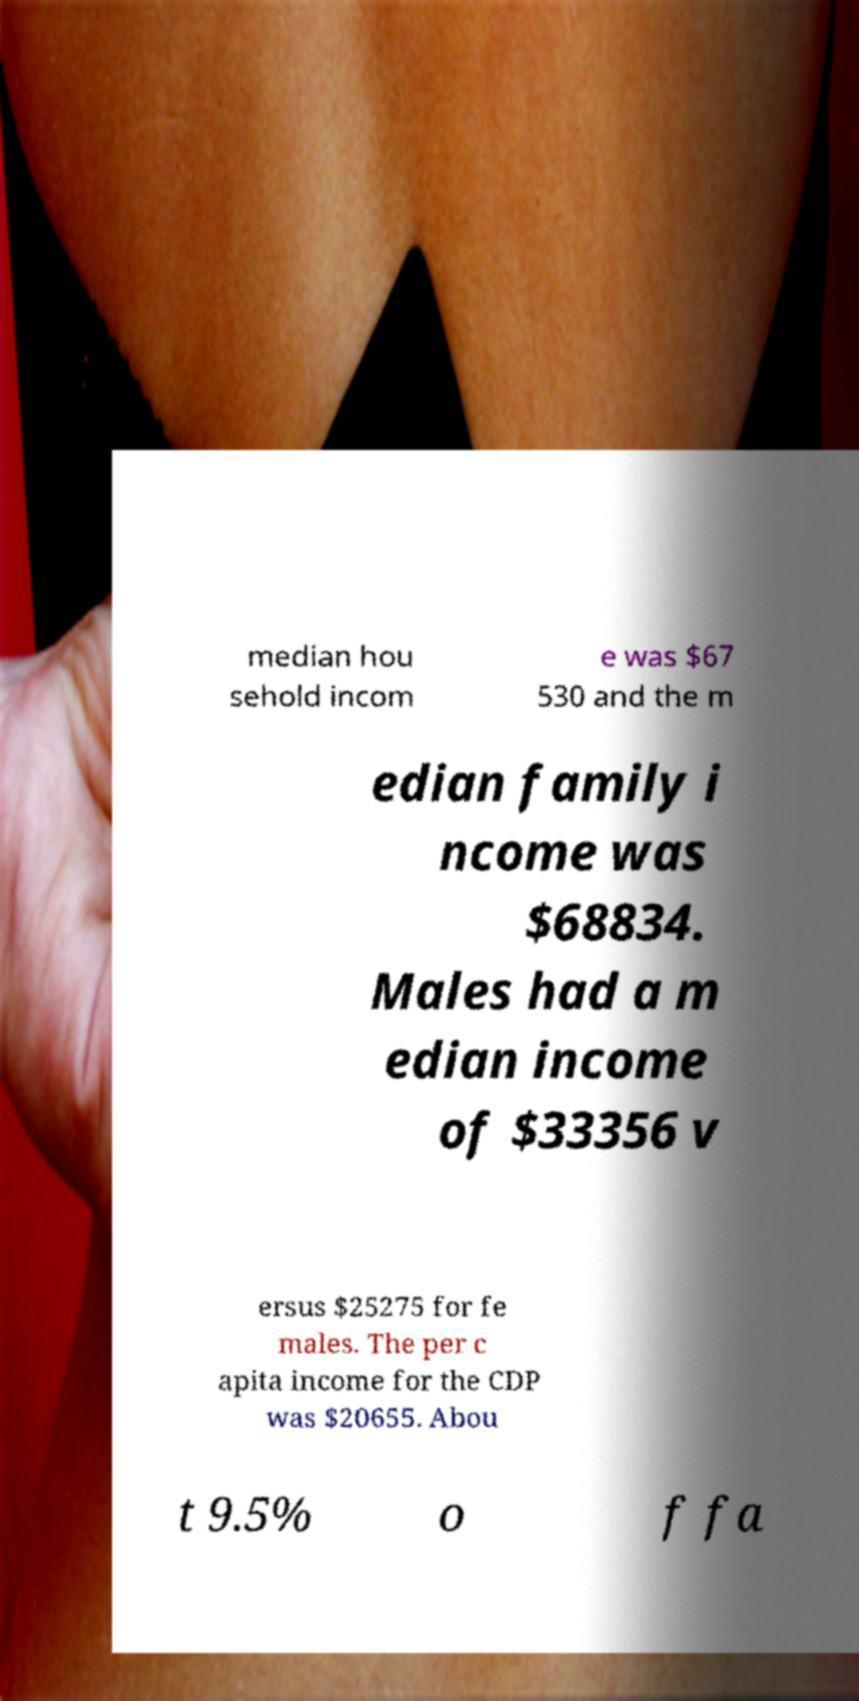There's text embedded in this image that I need extracted. Can you transcribe it verbatim? median hou sehold incom e was $67 530 and the m edian family i ncome was $68834. Males had a m edian income of $33356 v ersus $25275 for fe males. The per c apita income for the CDP was $20655. Abou t 9.5% o f fa 